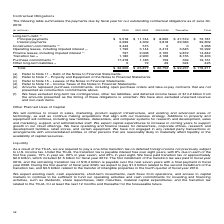According to Microsoft Corporation's financial document, Why has $14.2 billion been excluded from other long-term liabilities? We have excluded long-term tax contingencies, other tax liabilities, and deferred income taxes of $14.2 billion from the amounts presented as the timing of these obligations is uncertain.. The document states: "(f) We have excluded long-term tax contingencies, other tax liabilities, and deferred income taxes of $14.2 billion from the amounts presented as the ..." Also, What do the purchase commitments represent? Amounts represent purchase commitments, including open purchase orders and take-or-pay contracts that are not presented as construction commitments above.. The document states: "(e) Amounts represent purchase commitments, including open purchase orders and take-or-pay contracts that are not presented as construction commitment..." Also, Where can the long-term debt be found? Refer to Note 11 – Debt of the Notes to Financial Statements.. The document states: "(a) Refer to Note 11 – Debt of the Notes to Financial Statements...." Also, can you calculate: How much do the top 3 contractual obligation terms add up to in 2020? Based on the calculation: 5,518 + 17,478+3,443, the result is 26439 (in millions). This is based on the information: "Purchase commitments (e) 17,478 1,185 159 339 19,161 Construction commitments (b) 3,443 515 0 0 3,958 Principal payments $ 5,518 $ 11,744 $ 8,000 $ 47,519 $ 72,781..." The key data points involved are: 17,478, 3,443, 5,518. Also, can you calculate: What are the construction commitments in 2020 as a percentage of the total contractual obligations? Based on the calculation: 3,443/32,505, the result is 10.59 (percentage). This is based on the information: "Total $ 32,505 $ 25,877 $ 20,752 $ 99,237 $ 178,371 Construction commitments (b) 3,443 515 0 0 3,958..." The key data points involved are: 3,443, 32,505. Also, can you calculate: What is the percentage change in interest payments from 2020 to 2021-2022? To answer this question, I need to perform calculations using the financial data. The calculation is: (4,309-2,299)/2,299, which equals 87.43 (percentage). This is based on the information: "Interest payments 2,299 4,309 3,818 29,383 39,809 Interest payments 2,299 4,309 3,818 29,383 39,809..." The key data points involved are: 2,299, 4,309. 